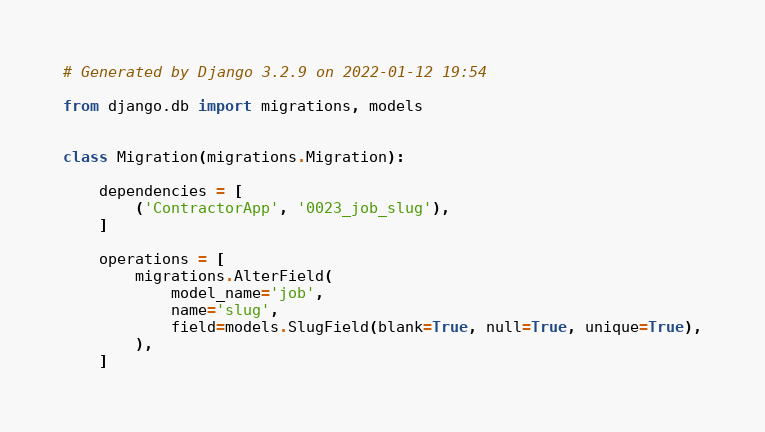Convert code to text. <code><loc_0><loc_0><loc_500><loc_500><_Python_># Generated by Django 3.2.9 on 2022-01-12 19:54

from django.db import migrations, models


class Migration(migrations.Migration):

    dependencies = [
        ('ContractorApp', '0023_job_slug'),
    ]

    operations = [
        migrations.AlterField(
            model_name='job',
            name='slug',
            field=models.SlugField(blank=True, null=True, unique=True),
        ),
    ]
</code> 